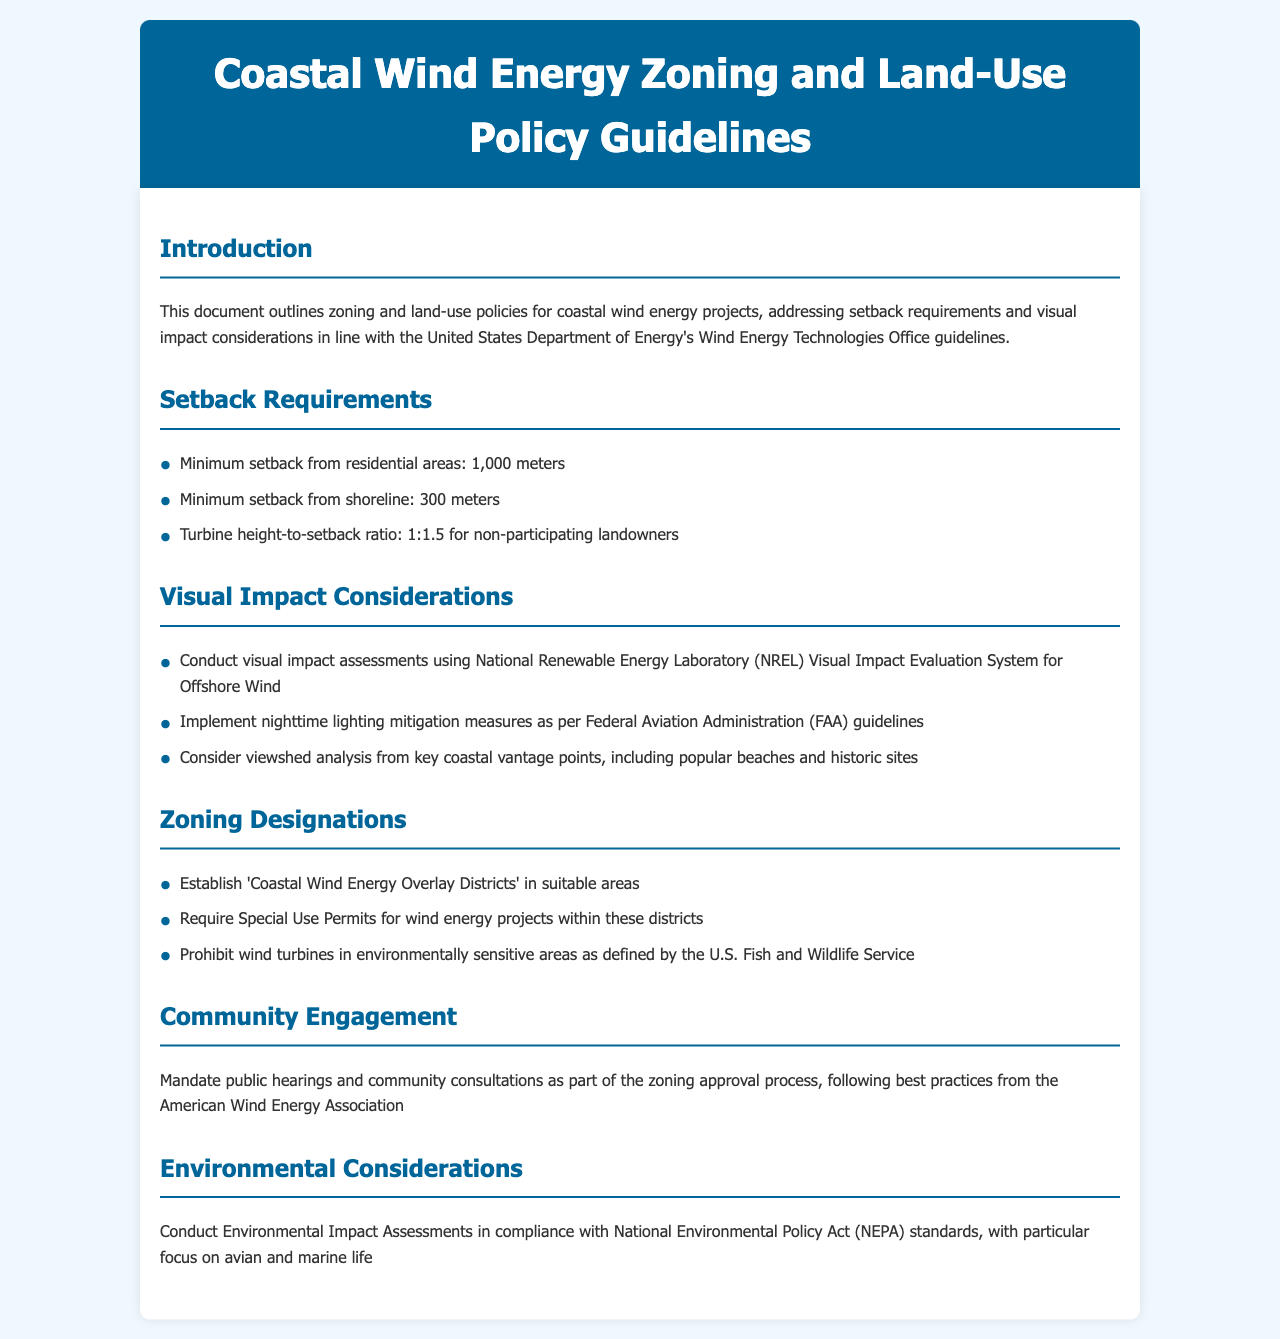What is the minimum setback from residential areas? The document states a minimum setback requirement of 1,000 meters from residential areas.
Answer: 1,000 meters What should be assessed using the NREL Visual Impact Evaluation System? The document specifies conducting visual impact assessments for offshore wind using this evaluation system.
Answer: Visual impact assessments What is the minimum setback from the shoreline? The policy outlines a minimum setback requirement of 300 meters from the shoreline.
Answer: 300 meters What ratio is required for turbine height to setback for non-participating landowners? The document indicates a turbine height-to-setback ratio of 1:1.5 for non-participating landowners.
Answer: 1:1.5 What areas are prohibited for wind turbines? The policy states that wind turbines are prohibited in environmentally sensitive areas as defined by the U.S. Fish and Wildlife Service.
Answer: Environmentally sensitive areas What type of permits are required for wind energy projects in designated districts? The document mentions that Special Use Permits are required for wind energy projects within Coastal Wind Energy Overlay Districts.
Answer: Special Use Permits What is mandated as part of the zoning approval process? According to the document, public hearings and community consultations are mandated as part of the zoning approval process.
Answer: Public hearings Which act must Environmental Impact Assessments comply with? The assessments must comply with the National Environmental Policy Act (NEPA) standards.
Answer: National Environmental Policy Act (NEPA) What is the main focus of Environmental Impact Assessments? The document specifies that the assessments should focus particularly on avian and marine life.
Answer: Avian and marine life 